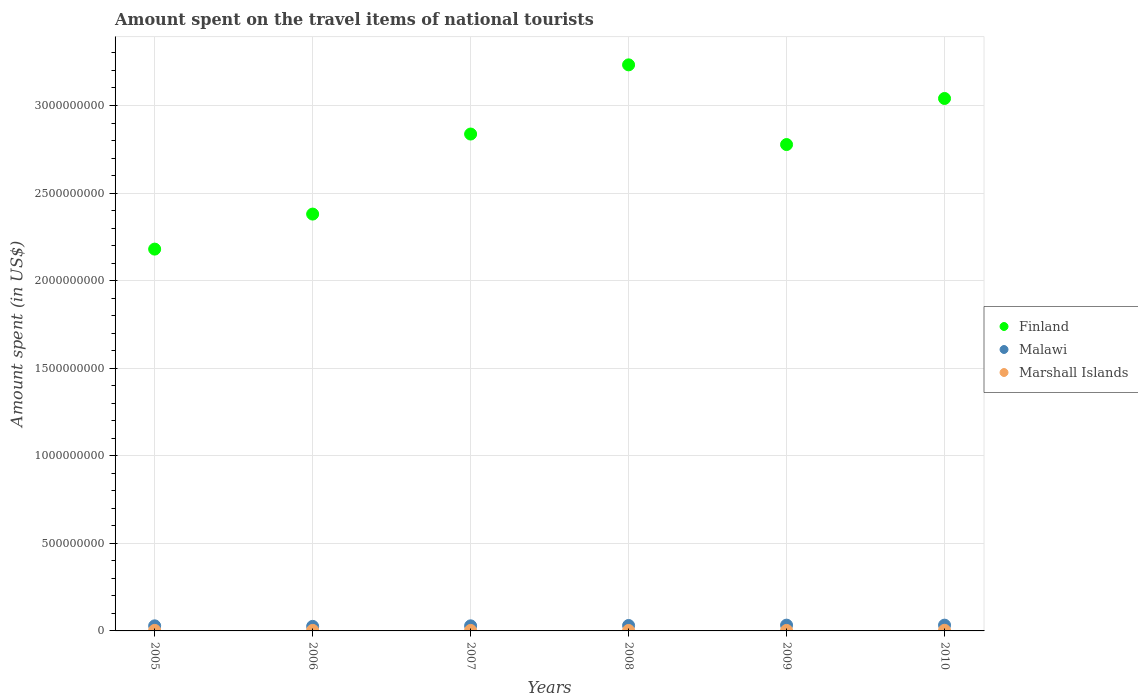How many different coloured dotlines are there?
Make the answer very short. 3. What is the amount spent on the travel items of national tourists in Marshall Islands in 2006?
Offer a very short reply. 3.10e+06. Across all years, what is the maximum amount spent on the travel items of national tourists in Finland?
Offer a very short reply. 3.23e+09. Across all years, what is the minimum amount spent on the travel items of national tourists in Marshall Islands?
Your response must be concise. 2.60e+06. In which year was the amount spent on the travel items of national tourists in Malawi maximum?
Offer a terse response. 2009. In which year was the amount spent on the travel items of national tourists in Finland minimum?
Your answer should be very brief. 2005. What is the total amount spent on the travel items of national tourists in Finland in the graph?
Offer a very short reply. 1.64e+1. What is the difference between the amount spent on the travel items of national tourists in Finland in 2009 and the amount spent on the travel items of national tourists in Malawi in 2008?
Provide a succinct answer. 2.75e+09. What is the average amount spent on the travel items of national tourists in Malawi per year?
Offer a very short reply. 3.02e+07. In the year 2006, what is the difference between the amount spent on the travel items of national tourists in Malawi and amount spent on the travel items of national tourists in Marshall Islands?
Make the answer very short. 2.29e+07. In how many years, is the amount spent on the travel items of national tourists in Finland greater than 1200000000 US$?
Provide a succinct answer. 6. What is the ratio of the amount spent on the travel items of national tourists in Finland in 2006 to that in 2008?
Ensure brevity in your answer.  0.74. What is the difference between the highest and the second highest amount spent on the travel items of national tourists in Malawi?
Make the answer very short. 0. What is the difference between the highest and the lowest amount spent on the travel items of national tourists in Marshall Islands?
Your response must be concise. 1.10e+06. In how many years, is the amount spent on the travel items of national tourists in Finland greater than the average amount spent on the travel items of national tourists in Finland taken over all years?
Your answer should be very brief. 4. Is it the case that in every year, the sum of the amount spent on the travel items of national tourists in Malawi and amount spent on the travel items of national tourists in Marshall Islands  is greater than the amount spent on the travel items of national tourists in Finland?
Offer a terse response. No. Does the amount spent on the travel items of national tourists in Marshall Islands monotonically increase over the years?
Ensure brevity in your answer.  No. Is the amount spent on the travel items of national tourists in Marshall Islands strictly less than the amount spent on the travel items of national tourists in Finland over the years?
Give a very brief answer. Yes. How many legend labels are there?
Provide a short and direct response. 3. What is the title of the graph?
Ensure brevity in your answer.  Amount spent on the travel items of national tourists. Does "Norway" appear as one of the legend labels in the graph?
Ensure brevity in your answer.  No. What is the label or title of the X-axis?
Your answer should be compact. Years. What is the label or title of the Y-axis?
Provide a succinct answer. Amount spent (in US$). What is the Amount spent (in US$) of Finland in 2005?
Your answer should be very brief. 2.18e+09. What is the Amount spent (in US$) of Malawi in 2005?
Offer a very short reply. 2.90e+07. What is the Amount spent (in US$) of Marshall Islands in 2005?
Give a very brief answer. 3.20e+06. What is the Amount spent (in US$) of Finland in 2006?
Offer a very short reply. 2.38e+09. What is the Amount spent (in US$) in Malawi in 2006?
Keep it short and to the point. 2.60e+07. What is the Amount spent (in US$) of Marshall Islands in 2006?
Your response must be concise. 3.10e+06. What is the Amount spent (in US$) in Finland in 2007?
Give a very brief answer. 2.84e+09. What is the Amount spent (in US$) in Malawi in 2007?
Your response must be concise. 2.90e+07. What is the Amount spent (in US$) of Marshall Islands in 2007?
Ensure brevity in your answer.  2.88e+06. What is the Amount spent (in US$) in Finland in 2008?
Make the answer very short. 3.23e+09. What is the Amount spent (in US$) in Malawi in 2008?
Your answer should be compact. 3.10e+07. What is the Amount spent (in US$) in Marshall Islands in 2008?
Ensure brevity in your answer.  2.60e+06. What is the Amount spent (in US$) of Finland in 2009?
Your answer should be very brief. 2.78e+09. What is the Amount spent (in US$) of Malawi in 2009?
Your answer should be very brief. 3.30e+07. What is the Amount spent (in US$) in Marshall Islands in 2009?
Make the answer very short. 2.90e+06. What is the Amount spent (in US$) in Finland in 2010?
Ensure brevity in your answer.  3.04e+09. What is the Amount spent (in US$) of Malawi in 2010?
Offer a very short reply. 3.30e+07. What is the Amount spent (in US$) of Marshall Islands in 2010?
Keep it short and to the point. 3.70e+06. Across all years, what is the maximum Amount spent (in US$) of Finland?
Ensure brevity in your answer.  3.23e+09. Across all years, what is the maximum Amount spent (in US$) of Malawi?
Make the answer very short. 3.30e+07. Across all years, what is the maximum Amount spent (in US$) in Marshall Islands?
Offer a terse response. 3.70e+06. Across all years, what is the minimum Amount spent (in US$) of Finland?
Keep it short and to the point. 2.18e+09. Across all years, what is the minimum Amount spent (in US$) of Malawi?
Your answer should be very brief. 2.60e+07. Across all years, what is the minimum Amount spent (in US$) of Marshall Islands?
Your response must be concise. 2.60e+06. What is the total Amount spent (in US$) in Finland in the graph?
Ensure brevity in your answer.  1.64e+1. What is the total Amount spent (in US$) of Malawi in the graph?
Make the answer very short. 1.81e+08. What is the total Amount spent (in US$) of Marshall Islands in the graph?
Your response must be concise. 1.84e+07. What is the difference between the Amount spent (in US$) in Finland in 2005 and that in 2006?
Offer a terse response. -2.00e+08. What is the difference between the Amount spent (in US$) of Malawi in 2005 and that in 2006?
Offer a very short reply. 3.00e+06. What is the difference between the Amount spent (in US$) of Finland in 2005 and that in 2007?
Provide a short and direct response. -6.57e+08. What is the difference between the Amount spent (in US$) in Marshall Islands in 2005 and that in 2007?
Ensure brevity in your answer.  3.20e+05. What is the difference between the Amount spent (in US$) in Finland in 2005 and that in 2008?
Your answer should be compact. -1.05e+09. What is the difference between the Amount spent (in US$) of Malawi in 2005 and that in 2008?
Ensure brevity in your answer.  -2.00e+06. What is the difference between the Amount spent (in US$) of Finland in 2005 and that in 2009?
Ensure brevity in your answer.  -5.97e+08. What is the difference between the Amount spent (in US$) of Finland in 2005 and that in 2010?
Your answer should be very brief. -8.60e+08. What is the difference between the Amount spent (in US$) in Malawi in 2005 and that in 2010?
Provide a succinct answer. -4.00e+06. What is the difference between the Amount spent (in US$) of Marshall Islands in 2005 and that in 2010?
Your answer should be compact. -5.00e+05. What is the difference between the Amount spent (in US$) of Finland in 2006 and that in 2007?
Keep it short and to the point. -4.57e+08. What is the difference between the Amount spent (in US$) of Finland in 2006 and that in 2008?
Provide a short and direct response. -8.52e+08. What is the difference between the Amount spent (in US$) of Malawi in 2006 and that in 2008?
Give a very brief answer. -5.00e+06. What is the difference between the Amount spent (in US$) in Marshall Islands in 2006 and that in 2008?
Keep it short and to the point. 5.00e+05. What is the difference between the Amount spent (in US$) in Finland in 2006 and that in 2009?
Keep it short and to the point. -3.97e+08. What is the difference between the Amount spent (in US$) of Malawi in 2006 and that in 2009?
Keep it short and to the point. -7.00e+06. What is the difference between the Amount spent (in US$) of Finland in 2006 and that in 2010?
Ensure brevity in your answer.  -6.60e+08. What is the difference between the Amount spent (in US$) in Malawi in 2006 and that in 2010?
Your answer should be very brief. -7.00e+06. What is the difference between the Amount spent (in US$) of Marshall Islands in 2006 and that in 2010?
Provide a succinct answer. -6.00e+05. What is the difference between the Amount spent (in US$) of Finland in 2007 and that in 2008?
Your response must be concise. -3.95e+08. What is the difference between the Amount spent (in US$) of Malawi in 2007 and that in 2008?
Keep it short and to the point. -2.00e+06. What is the difference between the Amount spent (in US$) of Finland in 2007 and that in 2009?
Provide a short and direct response. 6.00e+07. What is the difference between the Amount spent (in US$) in Malawi in 2007 and that in 2009?
Provide a short and direct response. -4.00e+06. What is the difference between the Amount spent (in US$) in Marshall Islands in 2007 and that in 2009?
Offer a very short reply. -2.00e+04. What is the difference between the Amount spent (in US$) in Finland in 2007 and that in 2010?
Provide a short and direct response. -2.03e+08. What is the difference between the Amount spent (in US$) in Marshall Islands in 2007 and that in 2010?
Keep it short and to the point. -8.20e+05. What is the difference between the Amount spent (in US$) in Finland in 2008 and that in 2009?
Your response must be concise. 4.55e+08. What is the difference between the Amount spent (in US$) of Malawi in 2008 and that in 2009?
Make the answer very short. -2.00e+06. What is the difference between the Amount spent (in US$) in Finland in 2008 and that in 2010?
Provide a succinct answer. 1.92e+08. What is the difference between the Amount spent (in US$) of Malawi in 2008 and that in 2010?
Offer a very short reply. -2.00e+06. What is the difference between the Amount spent (in US$) in Marshall Islands in 2008 and that in 2010?
Provide a short and direct response. -1.10e+06. What is the difference between the Amount spent (in US$) of Finland in 2009 and that in 2010?
Give a very brief answer. -2.63e+08. What is the difference between the Amount spent (in US$) of Marshall Islands in 2009 and that in 2010?
Ensure brevity in your answer.  -8.00e+05. What is the difference between the Amount spent (in US$) in Finland in 2005 and the Amount spent (in US$) in Malawi in 2006?
Your response must be concise. 2.15e+09. What is the difference between the Amount spent (in US$) of Finland in 2005 and the Amount spent (in US$) of Marshall Islands in 2006?
Ensure brevity in your answer.  2.18e+09. What is the difference between the Amount spent (in US$) in Malawi in 2005 and the Amount spent (in US$) in Marshall Islands in 2006?
Give a very brief answer. 2.59e+07. What is the difference between the Amount spent (in US$) of Finland in 2005 and the Amount spent (in US$) of Malawi in 2007?
Your answer should be compact. 2.15e+09. What is the difference between the Amount spent (in US$) in Finland in 2005 and the Amount spent (in US$) in Marshall Islands in 2007?
Give a very brief answer. 2.18e+09. What is the difference between the Amount spent (in US$) in Malawi in 2005 and the Amount spent (in US$) in Marshall Islands in 2007?
Provide a succinct answer. 2.61e+07. What is the difference between the Amount spent (in US$) of Finland in 2005 and the Amount spent (in US$) of Malawi in 2008?
Make the answer very short. 2.15e+09. What is the difference between the Amount spent (in US$) in Finland in 2005 and the Amount spent (in US$) in Marshall Islands in 2008?
Provide a succinct answer. 2.18e+09. What is the difference between the Amount spent (in US$) of Malawi in 2005 and the Amount spent (in US$) of Marshall Islands in 2008?
Keep it short and to the point. 2.64e+07. What is the difference between the Amount spent (in US$) of Finland in 2005 and the Amount spent (in US$) of Malawi in 2009?
Keep it short and to the point. 2.15e+09. What is the difference between the Amount spent (in US$) in Finland in 2005 and the Amount spent (in US$) in Marshall Islands in 2009?
Keep it short and to the point. 2.18e+09. What is the difference between the Amount spent (in US$) of Malawi in 2005 and the Amount spent (in US$) of Marshall Islands in 2009?
Your response must be concise. 2.61e+07. What is the difference between the Amount spent (in US$) of Finland in 2005 and the Amount spent (in US$) of Malawi in 2010?
Your answer should be compact. 2.15e+09. What is the difference between the Amount spent (in US$) in Finland in 2005 and the Amount spent (in US$) in Marshall Islands in 2010?
Offer a terse response. 2.18e+09. What is the difference between the Amount spent (in US$) of Malawi in 2005 and the Amount spent (in US$) of Marshall Islands in 2010?
Provide a succinct answer. 2.53e+07. What is the difference between the Amount spent (in US$) of Finland in 2006 and the Amount spent (in US$) of Malawi in 2007?
Provide a short and direct response. 2.35e+09. What is the difference between the Amount spent (in US$) in Finland in 2006 and the Amount spent (in US$) in Marshall Islands in 2007?
Your answer should be compact. 2.38e+09. What is the difference between the Amount spent (in US$) in Malawi in 2006 and the Amount spent (in US$) in Marshall Islands in 2007?
Your answer should be compact. 2.31e+07. What is the difference between the Amount spent (in US$) of Finland in 2006 and the Amount spent (in US$) of Malawi in 2008?
Keep it short and to the point. 2.35e+09. What is the difference between the Amount spent (in US$) in Finland in 2006 and the Amount spent (in US$) in Marshall Islands in 2008?
Provide a short and direct response. 2.38e+09. What is the difference between the Amount spent (in US$) in Malawi in 2006 and the Amount spent (in US$) in Marshall Islands in 2008?
Your answer should be very brief. 2.34e+07. What is the difference between the Amount spent (in US$) in Finland in 2006 and the Amount spent (in US$) in Malawi in 2009?
Keep it short and to the point. 2.35e+09. What is the difference between the Amount spent (in US$) in Finland in 2006 and the Amount spent (in US$) in Marshall Islands in 2009?
Keep it short and to the point. 2.38e+09. What is the difference between the Amount spent (in US$) of Malawi in 2006 and the Amount spent (in US$) of Marshall Islands in 2009?
Give a very brief answer. 2.31e+07. What is the difference between the Amount spent (in US$) in Finland in 2006 and the Amount spent (in US$) in Malawi in 2010?
Offer a terse response. 2.35e+09. What is the difference between the Amount spent (in US$) of Finland in 2006 and the Amount spent (in US$) of Marshall Islands in 2010?
Offer a very short reply. 2.38e+09. What is the difference between the Amount spent (in US$) of Malawi in 2006 and the Amount spent (in US$) of Marshall Islands in 2010?
Your response must be concise. 2.23e+07. What is the difference between the Amount spent (in US$) of Finland in 2007 and the Amount spent (in US$) of Malawi in 2008?
Give a very brief answer. 2.81e+09. What is the difference between the Amount spent (in US$) of Finland in 2007 and the Amount spent (in US$) of Marshall Islands in 2008?
Offer a terse response. 2.83e+09. What is the difference between the Amount spent (in US$) of Malawi in 2007 and the Amount spent (in US$) of Marshall Islands in 2008?
Provide a succinct answer. 2.64e+07. What is the difference between the Amount spent (in US$) in Finland in 2007 and the Amount spent (in US$) in Malawi in 2009?
Give a very brief answer. 2.80e+09. What is the difference between the Amount spent (in US$) of Finland in 2007 and the Amount spent (in US$) of Marshall Islands in 2009?
Offer a very short reply. 2.83e+09. What is the difference between the Amount spent (in US$) in Malawi in 2007 and the Amount spent (in US$) in Marshall Islands in 2009?
Provide a short and direct response. 2.61e+07. What is the difference between the Amount spent (in US$) of Finland in 2007 and the Amount spent (in US$) of Malawi in 2010?
Keep it short and to the point. 2.80e+09. What is the difference between the Amount spent (in US$) of Finland in 2007 and the Amount spent (in US$) of Marshall Islands in 2010?
Make the answer very short. 2.83e+09. What is the difference between the Amount spent (in US$) in Malawi in 2007 and the Amount spent (in US$) in Marshall Islands in 2010?
Make the answer very short. 2.53e+07. What is the difference between the Amount spent (in US$) of Finland in 2008 and the Amount spent (in US$) of Malawi in 2009?
Ensure brevity in your answer.  3.20e+09. What is the difference between the Amount spent (in US$) in Finland in 2008 and the Amount spent (in US$) in Marshall Islands in 2009?
Make the answer very short. 3.23e+09. What is the difference between the Amount spent (in US$) of Malawi in 2008 and the Amount spent (in US$) of Marshall Islands in 2009?
Offer a terse response. 2.81e+07. What is the difference between the Amount spent (in US$) of Finland in 2008 and the Amount spent (in US$) of Malawi in 2010?
Make the answer very short. 3.20e+09. What is the difference between the Amount spent (in US$) in Finland in 2008 and the Amount spent (in US$) in Marshall Islands in 2010?
Your answer should be very brief. 3.23e+09. What is the difference between the Amount spent (in US$) in Malawi in 2008 and the Amount spent (in US$) in Marshall Islands in 2010?
Your response must be concise. 2.73e+07. What is the difference between the Amount spent (in US$) in Finland in 2009 and the Amount spent (in US$) in Malawi in 2010?
Make the answer very short. 2.74e+09. What is the difference between the Amount spent (in US$) of Finland in 2009 and the Amount spent (in US$) of Marshall Islands in 2010?
Provide a succinct answer. 2.77e+09. What is the difference between the Amount spent (in US$) in Malawi in 2009 and the Amount spent (in US$) in Marshall Islands in 2010?
Give a very brief answer. 2.93e+07. What is the average Amount spent (in US$) of Finland per year?
Make the answer very short. 2.74e+09. What is the average Amount spent (in US$) of Malawi per year?
Keep it short and to the point. 3.02e+07. What is the average Amount spent (in US$) in Marshall Islands per year?
Offer a terse response. 3.06e+06. In the year 2005, what is the difference between the Amount spent (in US$) in Finland and Amount spent (in US$) in Malawi?
Ensure brevity in your answer.  2.15e+09. In the year 2005, what is the difference between the Amount spent (in US$) in Finland and Amount spent (in US$) in Marshall Islands?
Your response must be concise. 2.18e+09. In the year 2005, what is the difference between the Amount spent (in US$) in Malawi and Amount spent (in US$) in Marshall Islands?
Your response must be concise. 2.58e+07. In the year 2006, what is the difference between the Amount spent (in US$) in Finland and Amount spent (in US$) in Malawi?
Provide a short and direct response. 2.35e+09. In the year 2006, what is the difference between the Amount spent (in US$) in Finland and Amount spent (in US$) in Marshall Islands?
Your answer should be very brief. 2.38e+09. In the year 2006, what is the difference between the Amount spent (in US$) of Malawi and Amount spent (in US$) of Marshall Islands?
Your answer should be very brief. 2.29e+07. In the year 2007, what is the difference between the Amount spent (in US$) in Finland and Amount spent (in US$) in Malawi?
Offer a very short reply. 2.81e+09. In the year 2007, what is the difference between the Amount spent (in US$) in Finland and Amount spent (in US$) in Marshall Islands?
Provide a short and direct response. 2.83e+09. In the year 2007, what is the difference between the Amount spent (in US$) of Malawi and Amount spent (in US$) of Marshall Islands?
Give a very brief answer. 2.61e+07. In the year 2008, what is the difference between the Amount spent (in US$) in Finland and Amount spent (in US$) in Malawi?
Provide a short and direct response. 3.20e+09. In the year 2008, what is the difference between the Amount spent (in US$) of Finland and Amount spent (in US$) of Marshall Islands?
Provide a short and direct response. 3.23e+09. In the year 2008, what is the difference between the Amount spent (in US$) in Malawi and Amount spent (in US$) in Marshall Islands?
Keep it short and to the point. 2.84e+07. In the year 2009, what is the difference between the Amount spent (in US$) of Finland and Amount spent (in US$) of Malawi?
Keep it short and to the point. 2.74e+09. In the year 2009, what is the difference between the Amount spent (in US$) in Finland and Amount spent (in US$) in Marshall Islands?
Your response must be concise. 2.77e+09. In the year 2009, what is the difference between the Amount spent (in US$) of Malawi and Amount spent (in US$) of Marshall Islands?
Provide a short and direct response. 3.01e+07. In the year 2010, what is the difference between the Amount spent (in US$) of Finland and Amount spent (in US$) of Malawi?
Provide a succinct answer. 3.01e+09. In the year 2010, what is the difference between the Amount spent (in US$) in Finland and Amount spent (in US$) in Marshall Islands?
Your answer should be compact. 3.04e+09. In the year 2010, what is the difference between the Amount spent (in US$) in Malawi and Amount spent (in US$) in Marshall Islands?
Keep it short and to the point. 2.93e+07. What is the ratio of the Amount spent (in US$) in Finland in 2005 to that in 2006?
Your response must be concise. 0.92. What is the ratio of the Amount spent (in US$) of Malawi in 2005 to that in 2006?
Make the answer very short. 1.12. What is the ratio of the Amount spent (in US$) of Marshall Islands in 2005 to that in 2006?
Keep it short and to the point. 1.03. What is the ratio of the Amount spent (in US$) in Finland in 2005 to that in 2007?
Offer a terse response. 0.77. What is the ratio of the Amount spent (in US$) of Marshall Islands in 2005 to that in 2007?
Your response must be concise. 1.11. What is the ratio of the Amount spent (in US$) in Finland in 2005 to that in 2008?
Your answer should be very brief. 0.67. What is the ratio of the Amount spent (in US$) in Malawi in 2005 to that in 2008?
Your answer should be very brief. 0.94. What is the ratio of the Amount spent (in US$) of Marshall Islands in 2005 to that in 2008?
Give a very brief answer. 1.23. What is the ratio of the Amount spent (in US$) in Finland in 2005 to that in 2009?
Offer a very short reply. 0.79. What is the ratio of the Amount spent (in US$) in Malawi in 2005 to that in 2009?
Keep it short and to the point. 0.88. What is the ratio of the Amount spent (in US$) of Marshall Islands in 2005 to that in 2009?
Ensure brevity in your answer.  1.1. What is the ratio of the Amount spent (in US$) in Finland in 2005 to that in 2010?
Your answer should be compact. 0.72. What is the ratio of the Amount spent (in US$) of Malawi in 2005 to that in 2010?
Give a very brief answer. 0.88. What is the ratio of the Amount spent (in US$) in Marshall Islands in 2005 to that in 2010?
Your response must be concise. 0.86. What is the ratio of the Amount spent (in US$) in Finland in 2006 to that in 2007?
Make the answer very short. 0.84. What is the ratio of the Amount spent (in US$) in Malawi in 2006 to that in 2007?
Ensure brevity in your answer.  0.9. What is the ratio of the Amount spent (in US$) in Marshall Islands in 2006 to that in 2007?
Your answer should be compact. 1.08. What is the ratio of the Amount spent (in US$) in Finland in 2006 to that in 2008?
Offer a terse response. 0.74. What is the ratio of the Amount spent (in US$) in Malawi in 2006 to that in 2008?
Your answer should be very brief. 0.84. What is the ratio of the Amount spent (in US$) in Marshall Islands in 2006 to that in 2008?
Your answer should be very brief. 1.19. What is the ratio of the Amount spent (in US$) in Finland in 2006 to that in 2009?
Give a very brief answer. 0.86. What is the ratio of the Amount spent (in US$) of Malawi in 2006 to that in 2009?
Keep it short and to the point. 0.79. What is the ratio of the Amount spent (in US$) in Marshall Islands in 2006 to that in 2009?
Provide a succinct answer. 1.07. What is the ratio of the Amount spent (in US$) of Finland in 2006 to that in 2010?
Provide a succinct answer. 0.78. What is the ratio of the Amount spent (in US$) of Malawi in 2006 to that in 2010?
Offer a terse response. 0.79. What is the ratio of the Amount spent (in US$) of Marshall Islands in 2006 to that in 2010?
Provide a succinct answer. 0.84. What is the ratio of the Amount spent (in US$) of Finland in 2007 to that in 2008?
Keep it short and to the point. 0.88. What is the ratio of the Amount spent (in US$) of Malawi in 2007 to that in 2008?
Keep it short and to the point. 0.94. What is the ratio of the Amount spent (in US$) of Marshall Islands in 2007 to that in 2008?
Offer a terse response. 1.11. What is the ratio of the Amount spent (in US$) of Finland in 2007 to that in 2009?
Give a very brief answer. 1.02. What is the ratio of the Amount spent (in US$) of Malawi in 2007 to that in 2009?
Make the answer very short. 0.88. What is the ratio of the Amount spent (in US$) in Marshall Islands in 2007 to that in 2009?
Your answer should be compact. 0.99. What is the ratio of the Amount spent (in US$) of Finland in 2007 to that in 2010?
Your answer should be compact. 0.93. What is the ratio of the Amount spent (in US$) of Malawi in 2007 to that in 2010?
Provide a succinct answer. 0.88. What is the ratio of the Amount spent (in US$) of Marshall Islands in 2007 to that in 2010?
Your answer should be very brief. 0.78. What is the ratio of the Amount spent (in US$) of Finland in 2008 to that in 2009?
Provide a short and direct response. 1.16. What is the ratio of the Amount spent (in US$) of Malawi in 2008 to that in 2009?
Offer a terse response. 0.94. What is the ratio of the Amount spent (in US$) in Marshall Islands in 2008 to that in 2009?
Your answer should be compact. 0.9. What is the ratio of the Amount spent (in US$) of Finland in 2008 to that in 2010?
Your response must be concise. 1.06. What is the ratio of the Amount spent (in US$) in Malawi in 2008 to that in 2010?
Give a very brief answer. 0.94. What is the ratio of the Amount spent (in US$) of Marshall Islands in 2008 to that in 2010?
Keep it short and to the point. 0.7. What is the ratio of the Amount spent (in US$) of Finland in 2009 to that in 2010?
Ensure brevity in your answer.  0.91. What is the ratio of the Amount spent (in US$) in Malawi in 2009 to that in 2010?
Offer a terse response. 1. What is the ratio of the Amount spent (in US$) in Marshall Islands in 2009 to that in 2010?
Give a very brief answer. 0.78. What is the difference between the highest and the second highest Amount spent (in US$) of Finland?
Keep it short and to the point. 1.92e+08. What is the difference between the highest and the second highest Amount spent (in US$) in Malawi?
Keep it short and to the point. 0. What is the difference between the highest and the lowest Amount spent (in US$) in Finland?
Give a very brief answer. 1.05e+09. What is the difference between the highest and the lowest Amount spent (in US$) of Marshall Islands?
Offer a terse response. 1.10e+06. 